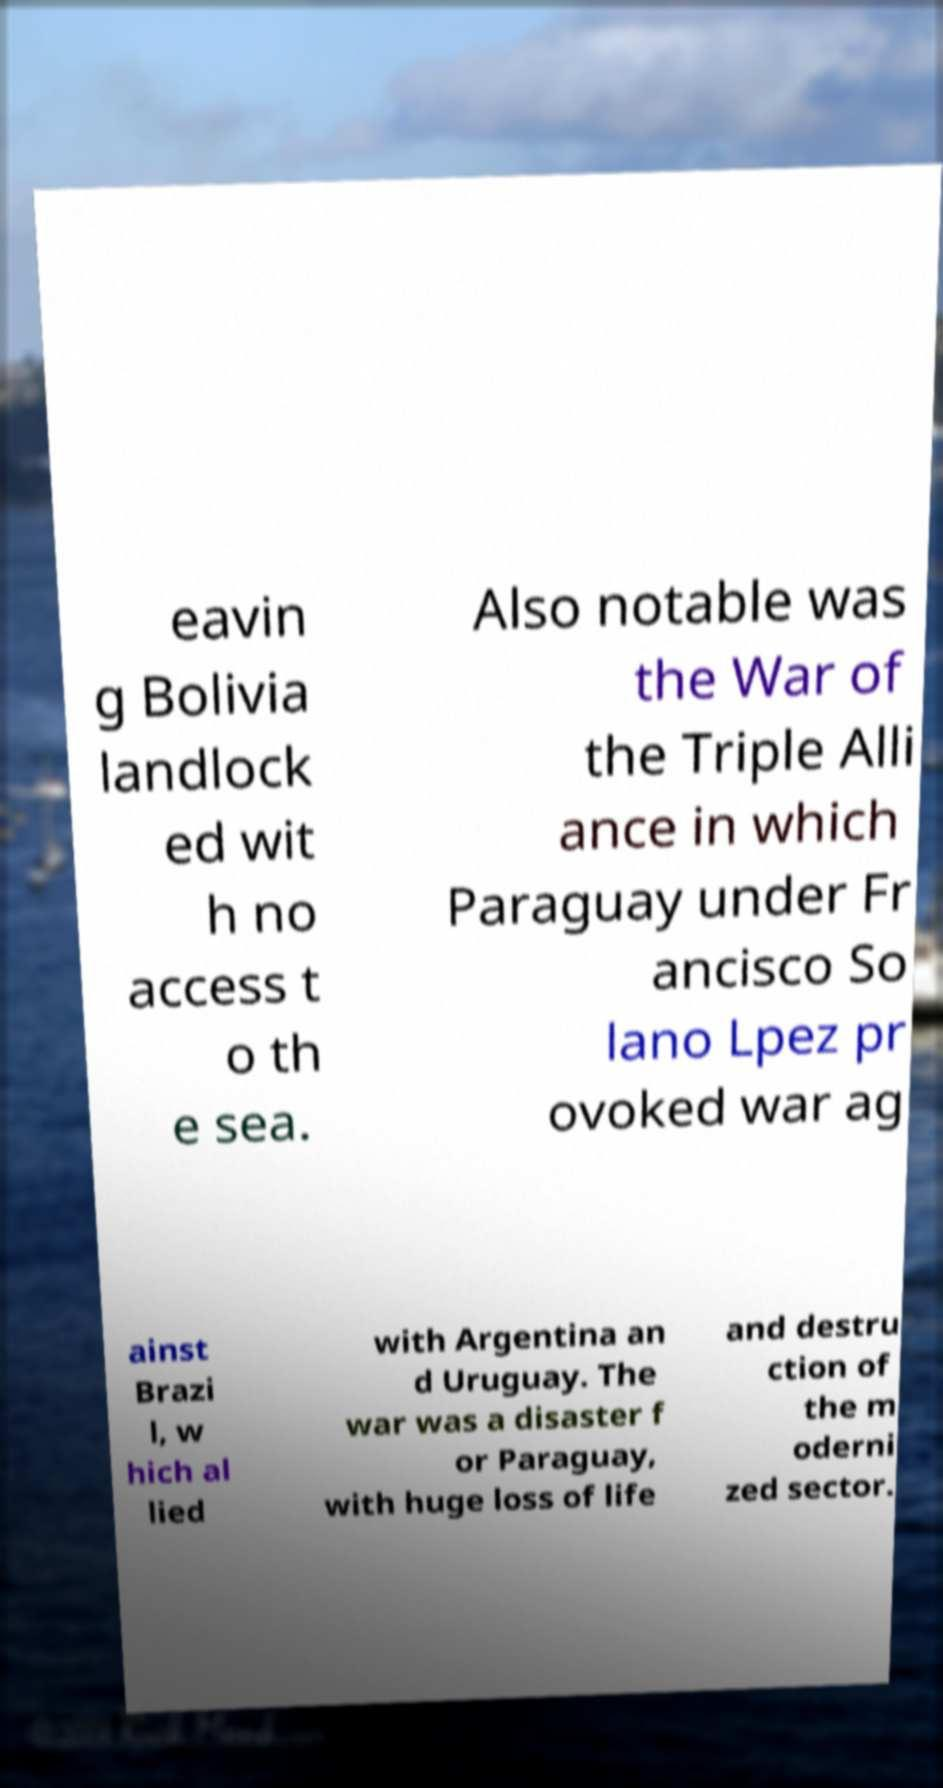Can you accurately transcribe the text from the provided image for me? eavin g Bolivia landlock ed wit h no access t o th e sea. Also notable was the War of the Triple Alli ance in which Paraguay under Fr ancisco So lano Lpez pr ovoked war ag ainst Brazi l, w hich al lied with Argentina an d Uruguay. The war was a disaster f or Paraguay, with huge loss of life and destru ction of the m oderni zed sector. 